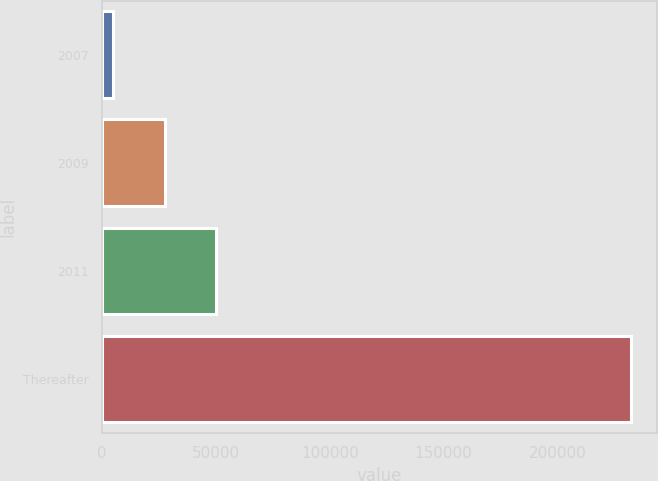Convert chart. <chart><loc_0><loc_0><loc_500><loc_500><bar_chart><fcel>2007<fcel>2009<fcel>2011<fcel>Thereafter<nl><fcel>4793<fcel>27521.6<fcel>50250.2<fcel>232079<nl></chart> 